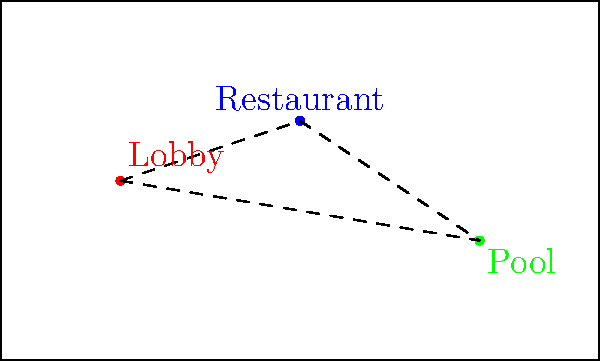In a boutique hotel layout, three key amenities (lobby, restaurant, and pool) form a triangle. If the distances between the lobby and restaurant is 5 units, restaurant and pool is 4 units, and pool and lobby is 7 units, what is the area of the triangular region formed by these amenities? To find the area of the triangle formed by the three amenities, we can use Heron's formula. Let's approach this step-by-step:

1) First, recall Heron's formula:
   $A = \sqrt{s(s-a)(s-b)(s-c)}$
   where $A$ is the area, $s$ is the semi-perimeter, and $a$, $b$, and $c$ are the side lengths of the triangle.

2) We're given the side lengths:
   $a = 5$ (lobby to restaurant)
   $b = 4$ (restaurant to pool)
   $c = 7$ (pool to lobby)

3) Calculate the semi-perimeter $s$:
   $s = \frac{a + b + c}{2} = \frac{5 + 4 + 7}{2} = \frac{16}{2} = 8$

4) Now, let's substitute these values into Heron's formula:
   $A = \sqrt{8(8-5)(8-4)(8-7)}$
   $A = \sqrt{8 \cdot 3 \cdot 4 \cdot 1}$
   $A = \sqrt{96}$

5) Simplify:
   $A = 4\sqrt{6}$ square units

This arrangement maximizes the efficiency of space usage while maintaining a triangular layout that allows easy access between all three amenities.
Answer: $4\sqrt{6}$ square units 